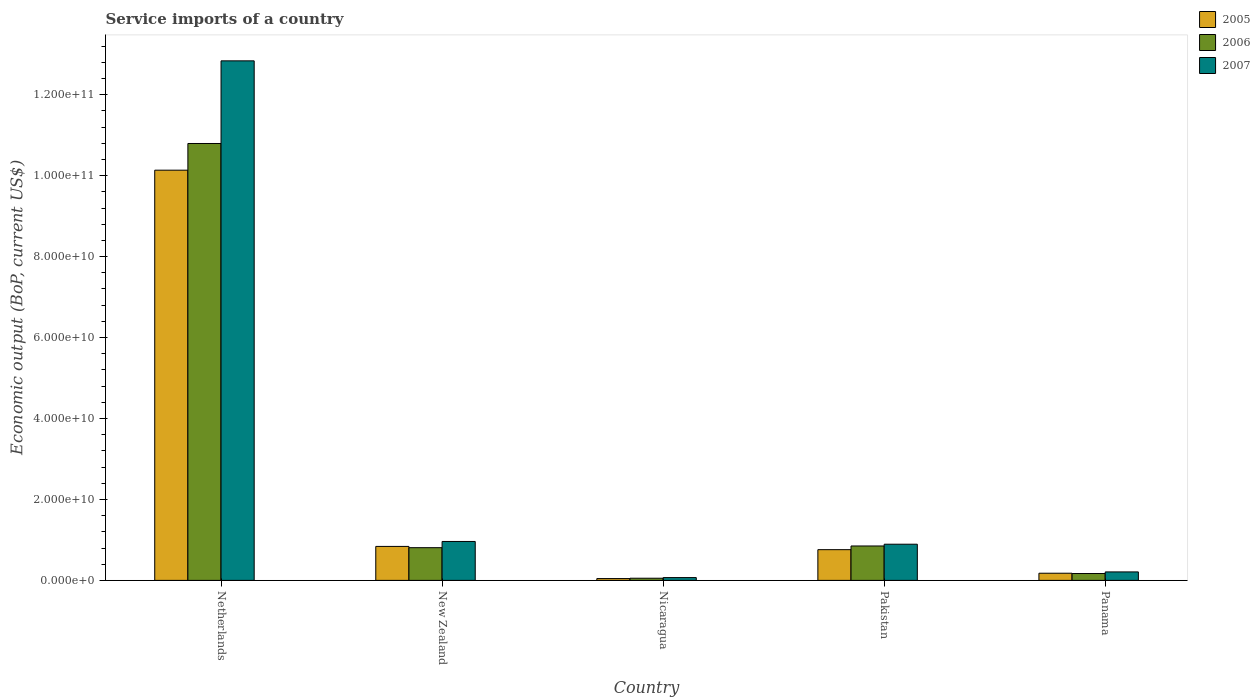How many different coloured bars are there?
Keep it short and to the point. 3. How many groups of bars are there?
Your response must be concise. 5. Are the number of bars per tick equal to the number of legend labels?
Provide a succinct answer. Yes. Are the number of bars on each tick of the X-axis equal?
Your answer should be very brief. Yes. How many bars are there on the 5th tick from the left?
Your answer should be very brief. 3. How many bars are there on the 5th tick from the right?
Your answer should be very brief. 3. What is the label of the 3rd group of bars from the left?
Offer a terse response. Nicaragua. What is the service imports in 2006 in Nicaragua?
Ensure brevity in your answer.  5.36e+08. Across all countries, what is the maximum service imports in 2007?
Ensure brevity in your answer.  1.28e+11. Across all countries, what is the minimum service imports in 2005?
Offer a terse response. 4.48e+08. In which country was the service imports in 2007 minimum?
Make the answer very short. Nicaragua. What is the total service imports in 2005 in the graph?
Your response must be concise. 1.20e+11. What is the difference between the service imports in 2006 in New Zealand and that in Pakistan?
Ensure brevity in your answer.  -4.19e+08. What is the difference between the service imports in 2006 in New Zealand and the service imports in 2007 in Panama?
Your answer should be compact. 5.99e+09. What is the average service imports in 2007 per country?
Your answer should be very brief. 2.99e+1. What is the difference between the service imports of/in 2005 and service imports of/in 2006 in Panama?
Your answer should be compact. 7.32e+07. In how many countries, is the service imports in 2005 greater than 8000000000 US$?
Ensure brevity in your answer.  2. What is the ratio of the service imports in 2007 in Netherlands to that in Nicaragua?
Keep it short and to the point. 185.68. What is the difference between the highest and the second highest service imports in 2006?
Your response must be concise. 9.94e+1. What is the difference between the highest and the lowest service imports in 2005?
Provide a short and direct response. 1.01e+11. Is the sum of the service imports in 2007 in Nicaragua and Pakistan greater than the maximum service imports in 2005 across all countries?
Offer a terse response. No. What does the 3rd bar from the left in Nicaragua represents?
Offer a very short reply. 2007. Are all the bars in the graph horizontal?
Provide a succinct answer. No. What is the difference between two consecutive major ticks on the Y-axis?
Provide a short and direct response. 2.00e+1. Where does the legend appear in the graph?
Your response must be concise. Top right. What is the title of the graph?
Offer a terse response. Service imports of a country. Does "1963" appear as one of the legend labels in the graph?
Provide a succinct answer. No. What is the label or title of the X-axis?
Ensure brevity in your answer.  Country. What is the label or title of the Y-axis?
Your answer should be compact. Economic output (BoP, current US$). What is the Economic output (BoP, current US$) of 2005 in Netherlands?
Give a very brief answer. 1.01e+11. What is the Economic output (BoP, current US$) in 2006 in Netherlands?
Offer a very short reply. 1.08e+11. What is the Economic output (BoP, current US$) in 2007 in Netherlands?
Your answer should be very brief. 1.28e+11. What is the Economic output (BoP, current US$) in 2005 in New Zealand?
Your response must be concise. 8.39e+09. What is the Economic output (BoP, current US$) in 2006 in New Zealand?
Provide a succinct answer. 8.08e+09. What is the Economic output (BoP, current US$) of 2007 in New Zealand?
Make the answer very short. 9.62e+09. What is the Economic output (BoP, current US$) in 2005 in Nicaragua?
Keep it short and to the point. 4.48e+08. What is the Economic output (BoP, current US$) of 2006 in Nicaragua?
Ensure brevity in your answer.  5.36e+08. What is the Economic output (BoP, current US$) in 2007 in Nicaragua?
Offer a terse response. 6.91e+08. What is the Economic output (BoP, current US$) of 2005 in Pakistan?
Your answer should be very brief. 7.59e+09. What is the Economic output (BoP, current US$) of 2006 in Pakistan?
Provide a succinct answer. 8.50e+09. What is the Economic output (BoP, current US$) of 2007 in Pakistan?
Offer a very short reply. 8.94e+09. What is the Economic output (BoP, current US$) of 2005 in Panama?
Offer a terse response. 1.77e+09. What is the Economic output (BoP, current US$) in 2006 in Panama?
Make the answer very short. 1.70e+09. What is the Economic output (BoP, current US$) in 2007 in Panama?
Offer a terse response. 2.09e+09. Across all countries, what is the maximum Economic output (BoP, current US$) in 2005?
Your answer should be compact. 1.01e+11. Across all countries, what is the maximum Economic output (BoP, current US$) in 2006?
Offer a very short reply. 1.08e+11. Across all countries, what is the maximum Economic output (BoP, current US$) in 2007?
Offer a terse response. 1.28e+11. Across all countries, what is the minimum Economic output (BoP, current US$) in 2005?
Ensure brevity in your answer.  4.48e+08. Across all countries, what is the minimum Economic output (BoP, current US$) of 2006?
Keep it short and to the point. 5.36e+08. Across all countries, what is the minimum Economic output (BoP, current US$) of 2007?
Make the answer very short. 6.91e+08. What is the total Economic output (BoP, current US$) in 2005 in the graph?
Provide a succinct answer. 1.20e+11. What is the total Economic output (BoP, current US$) of 2006 in the graph?
Provide a short and direct response. 1.27e+11. What is the total Economic output (BoP, current US$) of 2007 in the graph?
Give a very brief answer. 1.50e+11. What is the difference between the Economic output (BoP, current US$) of 2005 in Netherlands and that in New Zealand?
Offer a terse response. 9.30e+1. What is the difference between the Economic output (BoP, current US$) of 2006 in Netherlands and that in New Zealand?
Ensure brevity in your answer.  9.99e+1. What is the difference between the Economic output (BoP, current US$) in 2007 in Netherlands and that in New Zealand?
Make the answer very short. 1.19e+11. What is the difference between the Economic output (BoP, current US$) in 2005 in Netherlands and that in Nicaragua?
Your answer should be compact. 1.01e+11. What is the difference between the Economic output (BoP, current US$) of 2006 in Netherlands and that in Nicaragua?
Your answer should be compact. 1.07e+11. What is the difference between the Economic output (BoP, current US$) of 2007 in Netherlands and that in Nicaragua?
Provide a short and direct response. 1.28e+11. What is the difference between the Economic output (BoP, current US$) of 2005 in Netherlands and that in Pakistan?
Keep it short and to the point. 9.38e+1. What is the difference between the Economic output (BoP, current US$) in 2006 in Netherlands and that in Pakistan?
Your response must be concise. 9.94e+1. What is the difference between the Economic output (BoP, current US$) of 2007 in Netherlands and that in Pakistan?
Your answer should be compact. 1.19e+11. What is the difference between the Economic output (BoP, current US$) in 2005 in Netherlands and that in Panama?
Offer a terse response. 9.96e+1. What is the difference between the Economic output (BoP, current US$) of 2006 in Netherlands and that in Panama?
Provide a short and direct response. 1.06e+11. What is the difference between the Economic output (BoP, current US$) of 2007 in Netherlands and that in Panama?
Keep it short and to the point. 1.26e+11. What is the difference between the Economic output (BoP, current US$) of 2005 in New Zealand and that in Nicaragua?
Give a very brief answer. 7.94e+09. What is the difference between the Economic output (BoP, current US$) in 2006 in New Zealand and that in Nicaragua?
Make the answer very short. 7.55e+09. What is the difference between the Economic output (BoP, current US$) of 2007 in New Zealand and that in Nicaragua?
Offer a very short reply. 8.93e+09. What is the difference between the Economic output (BoP, current US$) in 2005 in New Zealand and that in Pakistan?
Provide a short and direct response. 8.03e+08. What is the difference between the Economic output (BoP, current US$) of 2006 in New Zealand and that in Pakistan?
Keep it short and to the point. -4.19e+08. What is the difference between the Economic output (BoP, current US$) of 2007 in New Zealand and that in Pakistan?
Keep it short and to the point. 6.78e+08. What is the difference between the Economic output (BoP, current US$) in 2005 in New Zealand and that in Panama?
Provide a short and direct response. 6.62e+09. What is the difference between the Economic output (BoP, current US$) in 2006 in New Zealand and that in Panama?
Your answer should be compact. 6.39e+09. What is the difference between the Economic output (BoP, current US$) of 2007 in New Zealand and that in Panama?
Give a very brief answer. 7.52e+09. What is the difference between the Economic output (BoP, current US$) in 2005 in Nicaragua and that in Pakistan?
Provide a short and direct response. -7.14e+09. What is the difference between the Economic output (BoP, current US$) in 2006 in Nicaragua and that in Pakistan?
Your answer should be compact. -7.97e+09. What is the difference between the Economic output (BoP, current US$) of 2007 in Nicaragua and that in Pakistan?
Your response must be concise. -8.25e+09. What is the difference between the Economic output (BoP, current US$) in 2005 in Nicaragua and that in Panama?
Your answer should be compact. -1.32e+09. What is the difference between the Economic output (BoP, current US$) in 2006 in Nicaragua and that in Panama?
Offer a very short reply. -1.16e+09. What is the difference between the Economic output (BoP, current US$) in 2007 in Nicaragua and that in Panama?
Offer a terse response. -1.40e+09. What is the difference between the Economic output (BoP, current US$) in 2005 in Pakistan and that in Panama?
Make the answer very short. 5.82e+09. What is the difference between the Economic output (BoP, current US$) of 2006 in Pakistan and that in Panama?
Provide a succinct answer. 6.81e+09. What is the difference between the Economic output (BoP, current US$) of 2007 in Pakistan and that in Panama?
Provide a succinct answer. 6.85e+09. What is the difference between the Economic output (BoP, current US$) of 2005 in Netherlands and the Economic output (BoP, current US$) of 2006 in New Zealand?
Provide a succinct answer. 9.33e+1. What is the difference between the Economic output (BoP, current US$) in 2005 in Netherlands and the Economic output (BoP, current US$) in 2007 in New Zealand?
Provide a short and direct response. 9.17e+1. What is the difference between the Economic output (BoP, current US$) of 2006 in Netherlands and the Economic output (BoP, current US$) of 2007 in New Zealand?
Your answer should be very brief. 9.83e+1. What is the difference between the Economic output (BoP, current US$) in 2005 in Netherlands and the Economic output (BoP, current US$) in 2006 in Nicaragua?
Provide a short and direct response. 1.01e+11. What is the difference between the Economic output (BoP, current US$) of 2005 in Netherlands and the Economic output (BoP, current US$) of 2007 in Nicaragua?
Provide a short and direct response. 1.01e+11. What is the difference between the Economic output (BoP, current US$) of 2006 in Netherlands and the Economic output (BoP, current US$) of 2007 in Nicaragua?
Offer a very short reply. 1.07e+11. What is the difference between the Economic output (BoP, current US$) in 2005 in Netherlands and the Economic output (BoP, current US$) in 2006 in Pakistan?
Offer a very short reply. 9.29e+1. What is the difference between the Economic output (BoP, current US$) of 2005 in Netherlands and the Economic output (BoP, current US$) of 2007 in Pakistan?
Give a very brief answer. 9.24e+1. What is the difference between the Economic output (BoP, current US$) of 2006 in Netherlands and the Economic output (BoP, current US$) of 2007 in Pakistan?
Offer a terse response. 9.90e+1. What is the difference between the Economic output (BoP, current US$) of 2005 in Netherlands and the Economic output (BoP, current US$) of 2006 in Panama?
Keep it short and to the point. 9.97e+1. What is the difference between the Economic output (BoP, current US$) of 2005 in Netherlands and the Economic output (BoP, current US$) of 2007 in Panama?
Offer a very short reply. 9.93e+1. What is the difference between the Economic output (BoP, current US$) in 2006 in Netherlands and the Economic output (BoP, current US$) in 2007 in Panama?
Keep it short and to the point. 1.06e+11. What is the difference between the Economic output (BoP, current US$) of 2005 in New Zealand and the Economic output (BoP, current US$) of 2006 in Nicaragua?
Your answer should be very brief. 7.86e+09. What is the difference between the Economic output (BoP, current US$) in 2005 in New Zealand and the Economic output (BoP, current US$) in 2007 in Nicaragua?
Keep it short and to the point. 7.70e+09. What is the difference between the Economic output (BoP, current US$) of 2006 in New Zealand and the Economic output (BoP, current US$) of 2007 in Nicaragua?
Ensure brevity in your answer.  7.39e+09. What is the difference between the Economic output (BoP, current US$) in 2005 in New Zealand and the Economic output (BoP, current US$) in 2006 in Pakistan?
Your answer should be very brief. -1.09e+08. What is the difference between the Economic output (BoP, current US$) in 2005 in New Zealand and the Economic output (BoP, current US$) in 2007 in Pakistan?
Your answer should be compact. -5.46e+08. What is the difference between the Economic output (BoP, current US$) in 2006 in New Zealand and the Economic output (BoP, current US$) in 2007 in Pakistan?
Ensure brevity in your answer.  -8.56e+08. What is the difference between the Economic output (BoP, current US$) in 2005 in New Zealand and the Economic output (BoP, current US$) in 2006 in Panama?
Make the answer very short. 6.70e+09. What is the difference between the Economic output (BoP, current US$) in 2005 in New Zealand and the Economic output (BoP, current US$) in 2007 in Panama?
Provide a short and direct response. 6.30e+09. What is the difference between the Economic output (BoP, current US$) of 2006 in New Zealand and the Economic output (BoP, current US$) of 2007 in Panama?
Offer a very short reply. 5.99e+09. What is the difference between the Economic output (BoP, current US$) in 2005 in Nicaragua and the Economic output (BoP, current US$) in 2006 in Pakistan?
Offer a terse response. -8.05e+09. What is the difference between the Economic output (BoP, current US$) of 2005 in Nicaragua and the Economic output (BoP, current US$) of 2007 in Pakistan?
Offer a terse response. -8.49e+09. What is the difference between the Economic output (BoP, current US$) in 2006 in Nicaragua and the Economic output (BoP, current US$) in 2007 in Pakistan?
Offer a terse response. -8.40e+09. What is the difference between the Economic output (BoP, current US$) in 2005 in Nicaragua and the Economic output (BoP, current US$) in 2006 in Panama?
Your answer should be very brief. -1.25e+09. What is the difference between the Economic output (BoP, current US$) of 2005 in Nicaragua and the Economic output (BoP, current US$) of 2007 in Panama?
Give a very brief answer. -1.64e+09. What is the difference between the Economic output (BoP, current US$) of 2006 in Nicaragua and the Economic output (BoP, current US$) of 2007 in Panama?
Your answer should be very brief. -1.56e+09. What is the difference between the Economic output (BoP, current US$) in 2005 in Pakistan and the Economic output (BoP, current US$) in 2006 in Panama?
Provide a short and direct response. 5.89e+09. What is the difference between the Economic output (BoP, current US$) of 2005 in Pakistan and the Economic output (BoP, current US$) of 2007 in Panama?
Your answer should be compact. 5.50e+09. What is the difference between the Economic output (BoP, current US$) of 2006 in Pakistan and the Economic output (BoP, current US$) of 2007 in Panama?
Offer a very short reply. 6.41e+09. What is the average Economic output (BoP, current US$) of 2005 per country?
Make the answer very short. 2.39e+1. What is the average Economic output (BoP, current US$) of 2006 per country?
Provide a succinct answer. 2.54e+1. What is the average Economic output (BoP, current US$) in 2007 per country?
Offer a very short reply. 2.99e+1. What is the difference between the Economic output (BoP, current US$) in 2005 and Economic output (BoP, current US$) in 2006 in Netherlands?
Ensure brevity in your answer.  -6.59e+09. What is the difference between the Economic output (BoP, current US$) in 2005 and Economic output (BoP, current US$) in 2007 in Netherlands?
Offer a very short reply. -2.70e+1. What is the difference between the Economic output (BoP, current US$) of 2006 and Economic output (BoP, current US$) of 2007 in Netherlands?
Your response must be concise. -2.04e+1. What is the difference between the Economic output (BoP, current US$) of 2005 and Economic output (BoP, current US$) of 2006 in New Zealand?
Provide a short and direct response. 3.11e+08. What is the difference between the Economic output (BoP, current US$) of 2005 and Economic output (BoP, current US$) of 2007 in New Zealand?
Your answer should be very brief. -1.22e+09. What is the difference between the Economic output (BoP, current US$) in 2006 and Economic output (BoP, current US$) in 2007 in New Zealand?
Your answer should be very brief. -1.53e+09. What is the difference between the Economic output (BoP, current US$) of 2005 and Economic output (BoP, current US$) of 2006 in Nicaragua?
Offer a very short reply. -8.75e+07. What is the difference between the Economic output (BoP, current US$) in 2005 and Economic output (BoP, current US$) in 2007 in Nicaragua?
Provide a short and direct response. -2.43e+08. What is the difference between the Economic output (BoP, current US$) of 2006 and Economic output (BoP, current US$) of 2007 in Nicaragua?
Offer a terse response. -1.56e+08. What is the difference between the Economic output (BoP, current US$) of 2005 and Economic output (BoP, current US$) of 2006 in Pakistan?
Your response must be concise. -9.11e+08. What is the difference between the Economic output (BoP, current US$) in 2005 and Economic output (BoP, current US$) in 2007 in Pakistan?
Your answer should be compact. -1.35e+09. What is the difference between the Economic output (BoP, current US$) in 2006 and Economic output (BoP, current US$) in 2007 in Pakistan?
Your answer should be compact. -4.37e+08. What is the difference between the Economic output (BoP, current US$) in 2005 and Economic output (BoP, current US$) in 2006 in Panama?
Your answer should be very brief. 7.32e+07. What is the difference between the Economic output (BoP, current US$) of 2005 and Economic output (BoP, current US$) of 2007 in Panama?
Your answer should be compact. -3.24e+08. What is the difference between the Economic output (BoP, current US$) in 2006 and Economic output (BoP, current US$) in 2007 in Panama?
Offer a very short reply. -3.97e+08. What is the ratio of the Economic output (BoP, current US$) in 2005 in Netherlands to that in New Zealand?
Offer a terse response. 12.08. What is the ratio of the Economic output (BoP, current US$) in 2006 in Netherlands to that in New Zealand?
Your answer should be very brief. 13.36. What is the ratio of the Economic output (BoP, current US$) of 2007 in Netherlands to that in New Zealand?
Give a very brief answer. 13.35. What is the ratio of the Economic output (BoP, current US$) in 2005 in Netherlands to that in Nicaragua?
Your response must be concise. 226.13. What is the ratio of the Economic output (BoP, current US$) of 2006 in Netherlands to that in Nicaragua?
Provide a short and direct response. 201.5. What is the ratio of the Economic output (BoP, current US$) in 2007 in Netherlands to that in Nicaragua?
Keep it short and to the point. 185.68. What is the ratio of the Economic output (BoP, current US$) in 2005 in Netherlands to that in Pakistan?
Provide a succinct answer. 13.35. What is the ratio of the Economic output (BoP, current US$) of 2006 in Netherlands to that in Pakistan?
Make the answer very short. 12.7. What is the ratio of the Economic output (BoP, current US$) of 2007 in Netherlands to that in Pakistan?
Your answer should be compact. 14.36. What is the ratio of the Economic output (BoP, current US$) of 2005 in Netherlands to that in Panama?
Your answer should be very brief. 57.28. What is the ratio of the Economic output (BoP, current US$) in 2006 in Netherlands to that in Panama?
Ensure brevity in your answer.  63.63. What is the ratio of the Economic output (BoP, current US$) of 2007 in Netherlands to that in Panama?
Give a very brief answer. 61.33. What is the ratio of the Economic output (BoP, current US$) in 2005 in New Zealand to that in Nicaragua?
Offer a very short reply. 18.73. What is the ratio of the Economic output (BoP, current US$) in 2006 in New Zealand to that in Nicaragua?
Your answer should be very brief. 15.09. What is the ratio of the Economic output (BoP, current US$) of 2007 in New Zealand to that in Nicaragua?
Your answer should be compact. 13.91. What is the ratio of the Economic output (BoP, current US$) in 2005 in New Zealand to that in Pakistan?
Provide a succinct answer. 1.11. What is the ratio of the Economic output (BoP, current US$) of 2006 in New Zealand to that in Pakistan?
Your answer should be very brief. 0.95. What is the ratio of the Economic output (BoP, current US$) in 2007 in New Zealand to that in Pakistan?
Ensure brevity in your answer.  1.08. What is the ratio of the Economic output (BoP, current US$) of 2005 in New Zealand to that in Panama?
Make the answer very short. 4.74. What is the ratio of the Economic output (BoP, current US$) of 2006 in New Zealand to that in Panama?
Offer a very short reply. 4.76. What is the ratio of the Economic output (BoP, current US$) of 2007 in New Zealand to that in Panama?
Keep it short and to the point. 4.59. What is the ratio of the Economic output (BoP, current US$) in 2005 in Nicaragua to that in Pakistan?
Your response must be concise. 0.06. What is the ratio of the Economic output (BoP, current US$) in 2006 in Nicaragua to that in Pakistan?
Give a very brief answer. 0.06. What is the ratio of the Economic output (BoP, current US$) in 2007 in Nicaragua to that in Pakistan?
Ensure brevity in your answer.  0.08. What is the ratio of the Economic output (BoP, current US$) of 2005 in Nicaragua to that in Panama?
Offer a very short reply. 0.25. What is the ratio of the Economic output (BoP, current US$) of 2006 in Nicaragua to that in Panama?
Offer a terse response. 0.32. What is the ratio of the Economic output (BoP, current US$) of 2007 in Nicaragua to that in Panama?
Ensure brevity in your answer.  0.33. What is the ratio of the Economic output (BoP, current US$) in 2005 in Pakistan to that in Panama?
Make the answer very short. 4.29. What is the ratio of the Economic output (BoP, current US$) of 2006 in Pakistan to that in Panama?
Offer a very short reply. 5.01. What is the ratio of the Economic output (BoP, current US$) in 2007 in Pakistan to that in Panama?
Provide a succinct answer. 4.27. What is the difference between the highest and the second highest Economic output (BoP, current US$) of 2005?
Your response must be concise. 9.30e+1. What is the difference between the highest and the second highest Economic output (BoP, current US$) of 2006?
Your answer should be very brief. 9.94e+1. What is the difference between the highest and the second highest Economic output (BoP, current US$) in 2007?
Provide a succinct answer. 1.19e+11. What is the difference between the highest and the lowest Economic output (BoP, current US$) of 2005?
Ensure brevity in your answer.  1.01e+11. What is the difference between the highest and the lowest Economic output (BoP, current US$) in 2006?
Keep it short and to the point. 1.07e+11. What is the difference between the highest and the lowest Economic output (BoP, current US$) of 2007?
Ensure brevity in your answer.  1.28e+11. 